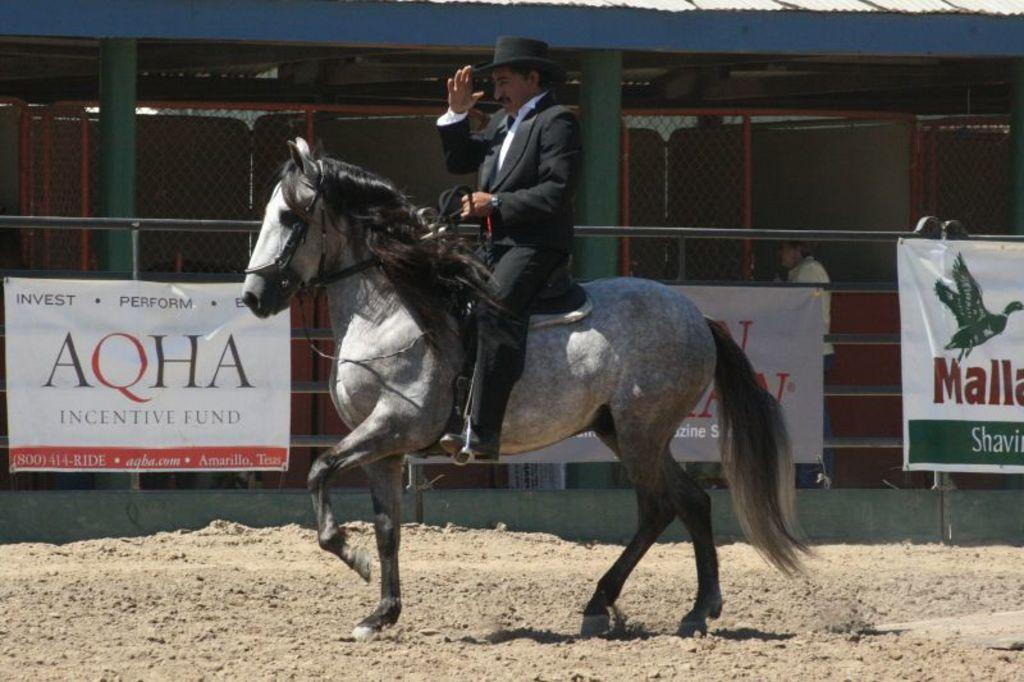What is the man in the image doing? The man is riding a horse in the image. What can be seen in the background of the image? There is a fence, banners, pillars, and a shed visible in the image. How many people are present in the image? There is one person, the man riding the horse, present in the image. What type of roof can be seen on the shed in the image? There is no roof visible on the shed in the image. Can you tell me how many rabbits are present in the image? There are no rabbits present in the image. 